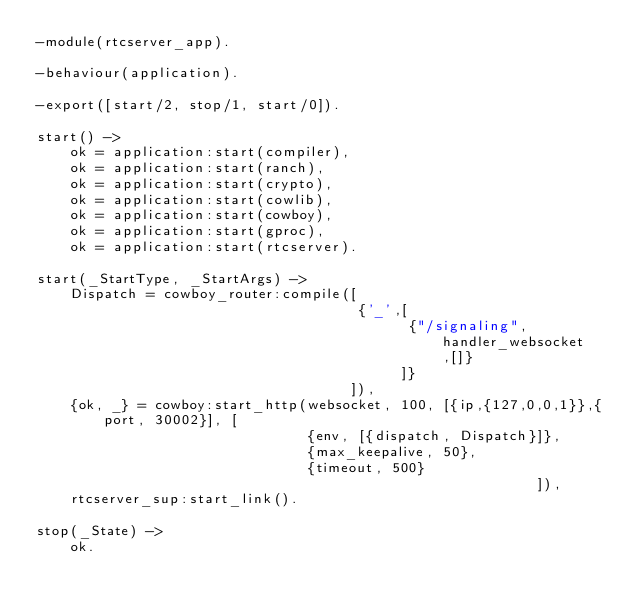Convert code to text. <code><loc_0><loc_0><loc_500><loc_500><_Erlang_>-module(rtcserver_app).

-behaviour(application).

-export([start/2, stop/1, start/0]).

start() ->
    ok = application:start(compiler),
    ok = application:start(ranch),
    ok = application:start(crypto),
    ok = application:start(cowlib),
    ok = application:start(cowboy),
    ok = application:start(gproc),
    ok = application:start(rtcserver).

start(_StartType, _StartArgs) ->
    Dispatch = cowboy_router:compile([
                                      {'_',[
                                            {"/signaling", handler_websocket,[]}
                                           ]}
                                     ]),
    {ok, _} = cowboy:start_http(websocket, 100, [{ip,{127,0,0,1}},{port, 30002}], [
                                {env, [{dispatch, Dispatch}]},
                                {max_keepalive, 50},
                                {timeout, 500}
                                                           ]),
    rtcserver_sup:start_link().

stop(_State) ->
    ok.


</code> 